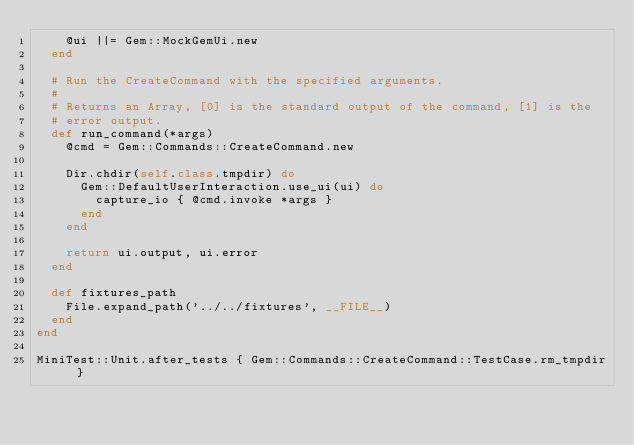Convert code to text. <code><loc_0><loc_0><loc_500><loc_500><_Ruby_>    @ui ||= Gem::MockGemUi.new
  end

  # Run the CreateCommand with the specified arguments.
  #
  # Returns an Array, [0] is the standard output of the command, [1] is the
  # error output.
  def run_command(*args)
    @cmd = Gem::Commands::CreateCommand.new

    Dir.chdir(self.class.tmpdir) do
      Gem::DefaultUserInteraction.use_ui(ui) do
        capture_io { @cmd.invoke *args }
      end
    end

    return ui.output, ui.error
  end

  def fixtures_path
    File.expand_path('../../fixtures', __FILE__)
  end
end

MiniTest::Unit.after_tests { Gem::Commands::CreateCommand::TestCase.rm_tmpdir }
</code> 